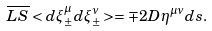Convert formula to latex. <formula><loc_0><loc_0><loc_500><loc_500>\overline { L S } < d \xi _ { \pm } ^ { \mu } d \xi _ { \pm } ^ { \nu } > = \mp 2 D \eta ^ { \mu \nu } d s .</formula> 